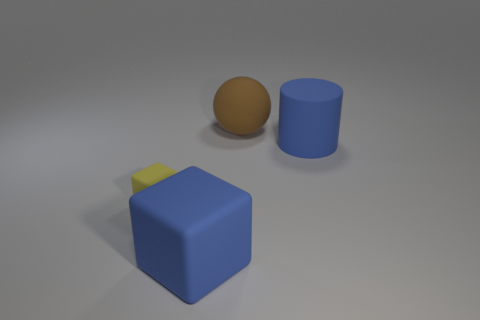Add 2 blue rubber blocks. How many objects exist? 6 Subtract 2 cubes. How many cubes are left? 0 Subtract all cylinders. How many objects are left? 3 Add 2 brown rubber things. How many brown rubber things are left? 3 Add 1 large cyan matte blocks. How many large cyan matte blocks exist? 1 Subtract 0 red spheres. How many objects are left? 4 Subtract all cyan cylinders. Subtract all brown balls. How many cylinders are left? 1 Subtract all blue cylinders. How many blue blocks are left? 1 Subtract all large brown objects. Subtract all brown balls. How many objects are left? 2 